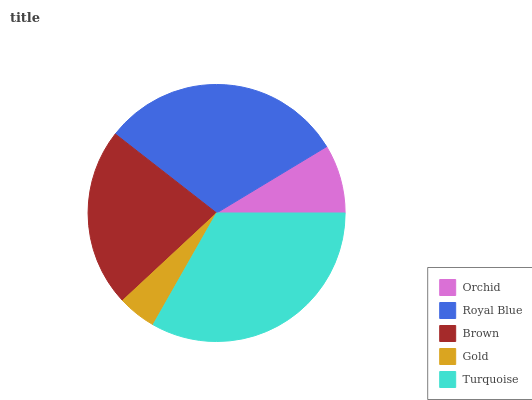Is Gold the minimum?
Answer yes or no. Yes. Is Turquoise the maximum?
Answer yes or no. Yes. Is Royal Blue the minimum?
Answer yes or no. No. Is Royal Blue the maximum?
Answer yes or no. No. Is Royal Blue greater than Orchid?
Answer yes or no. Yes. Is Orchid less than Royal Blue?
Answer yes or no. Yes. Is Orchid greater than Royal Blue?
Answer yes or no. No. Is Royal Blue less than Orchid?
Answer yes or no. No. Is Brown the high median?
Answer yes or no. Yes. Is Brown the low median?
Answer yes or no. Yes. Is Turquoise the high median?
Answer yes or no. No. Is Turquoise the low median?
Answer yes or no. No. 